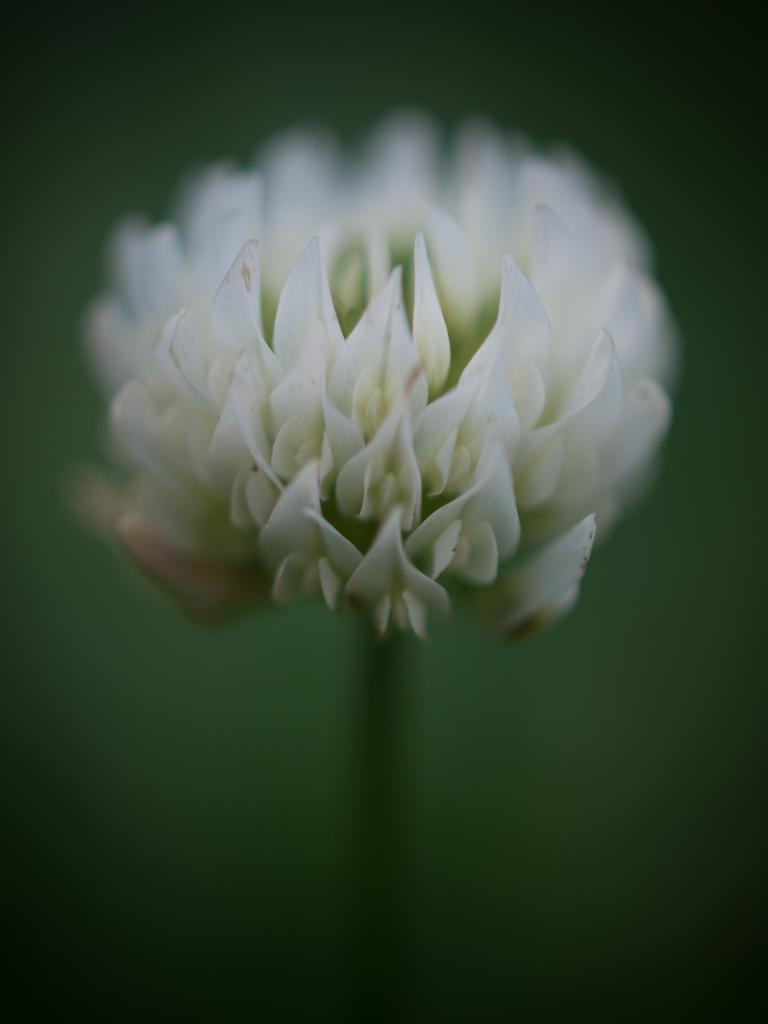What type of flower is in the image? There is a white-colored flower in the image. Can you describe the background of the image? The background of the image is blurred. How many snails can be seen crawling on the petals of the flower in the image? There are no snails visible on the flower in the image. What type of writing instrument is present in the image? There is no pen present in the image. What type of fruit is hanging from the flower in the image? There is no apple or any fruit hanging from the flower in the image. 